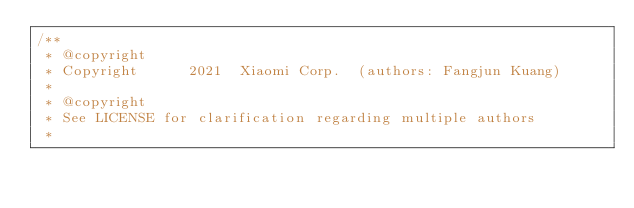<code> <loc_0><loc_0><loc_500><loc_500><_Cuda_>/**
 * @copyright
 * Copyright      2021  Xiaomi Corp.  (authors: Fangjun Kuang)
 *
 * @copyright
 * See LICENSE for clarification regarding multiple authors
 *</code> 